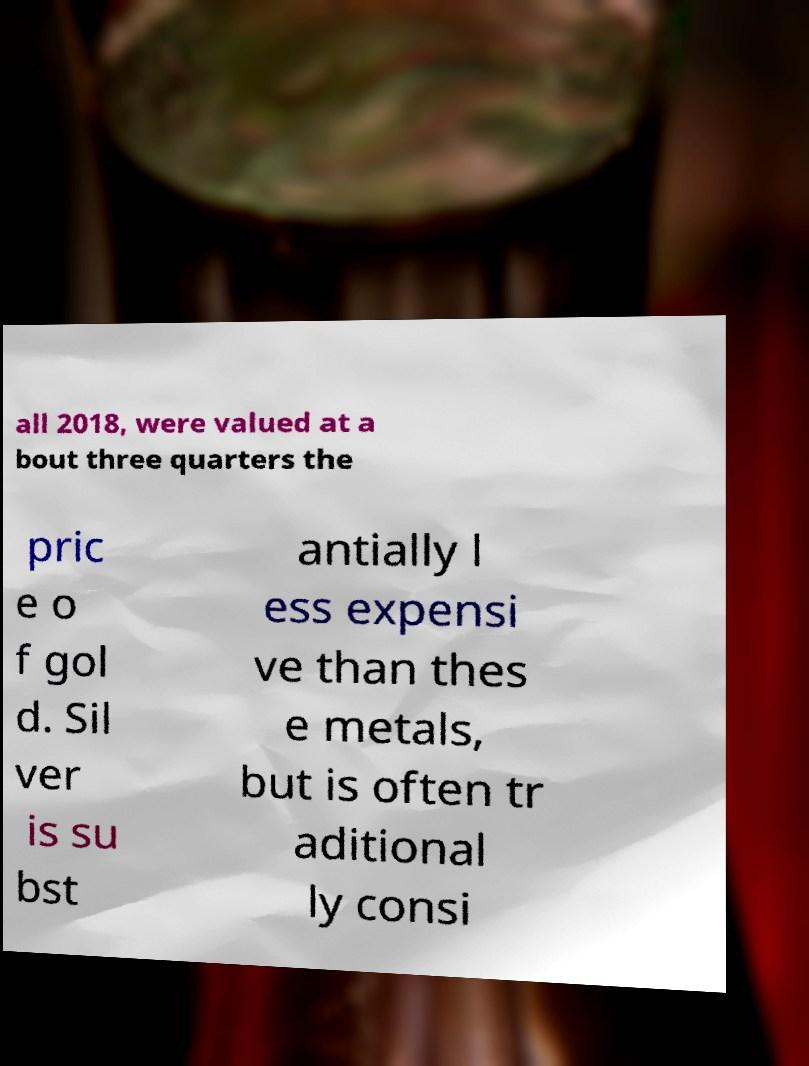Could you extract and type out the text from this image? all 2018, were valued at a bout three quarters the pric e o f gol d. Sil ver is su bst antially l ess expensi ve than thes e metals, but is often tr aditional ly consi 